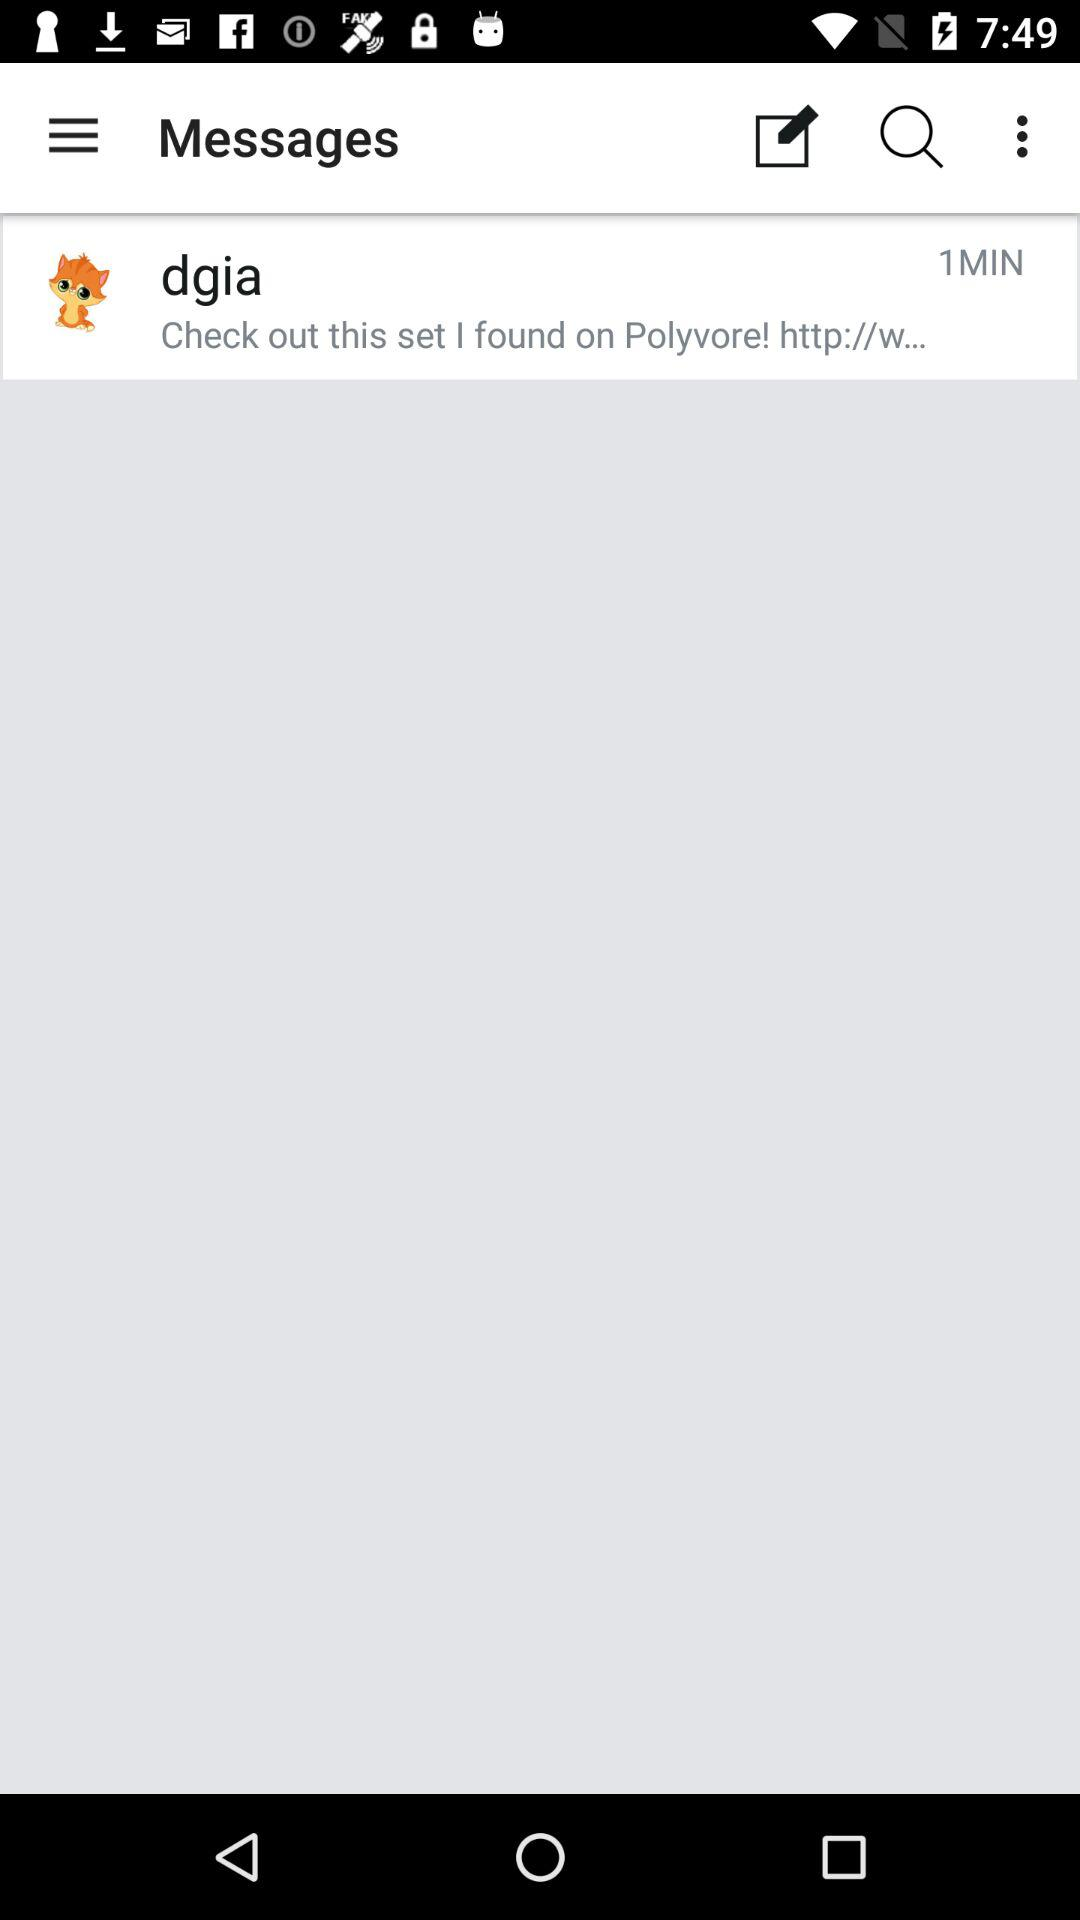How many minutes have passed since the message was sent?
Answer the question using a single word or phrase. 1 